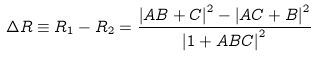Convert formula to latex. <formula><loc_0><loc_0><loc_500><loc_500>\Delta R \equiv R _ { 1 } - R _ { 2 } = \frac { \left | A B + C \right | ^ { 2 } - \left | A C + B \right | ^ { 2 } } { \left | 1 + A B C \right | ^ { 2 } }</formula> 